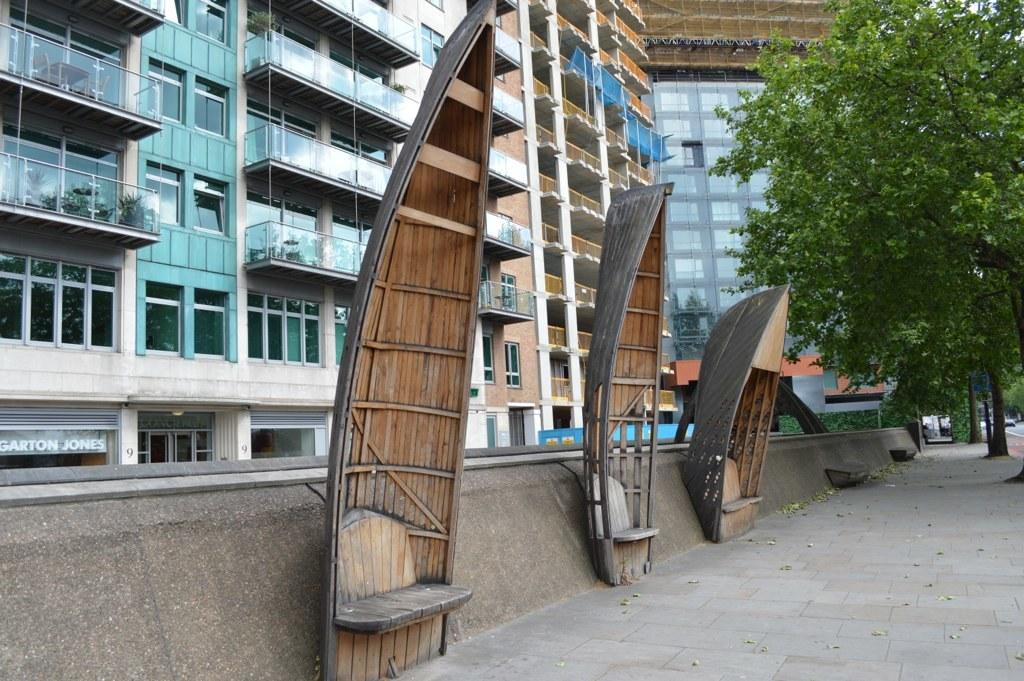What type of benches are in the image? There are boat-shaped wooden benches fixed to the wall in the image. What can be seen on the ground in the image? Dry leaves are visible in the image. What is visible in the background of the image? There are trees, a road, and glass buildings in the background of the image. What type of line can be seen on the receipt in the image? There is no receipt present in the image, so it is not possible to answer that question. 